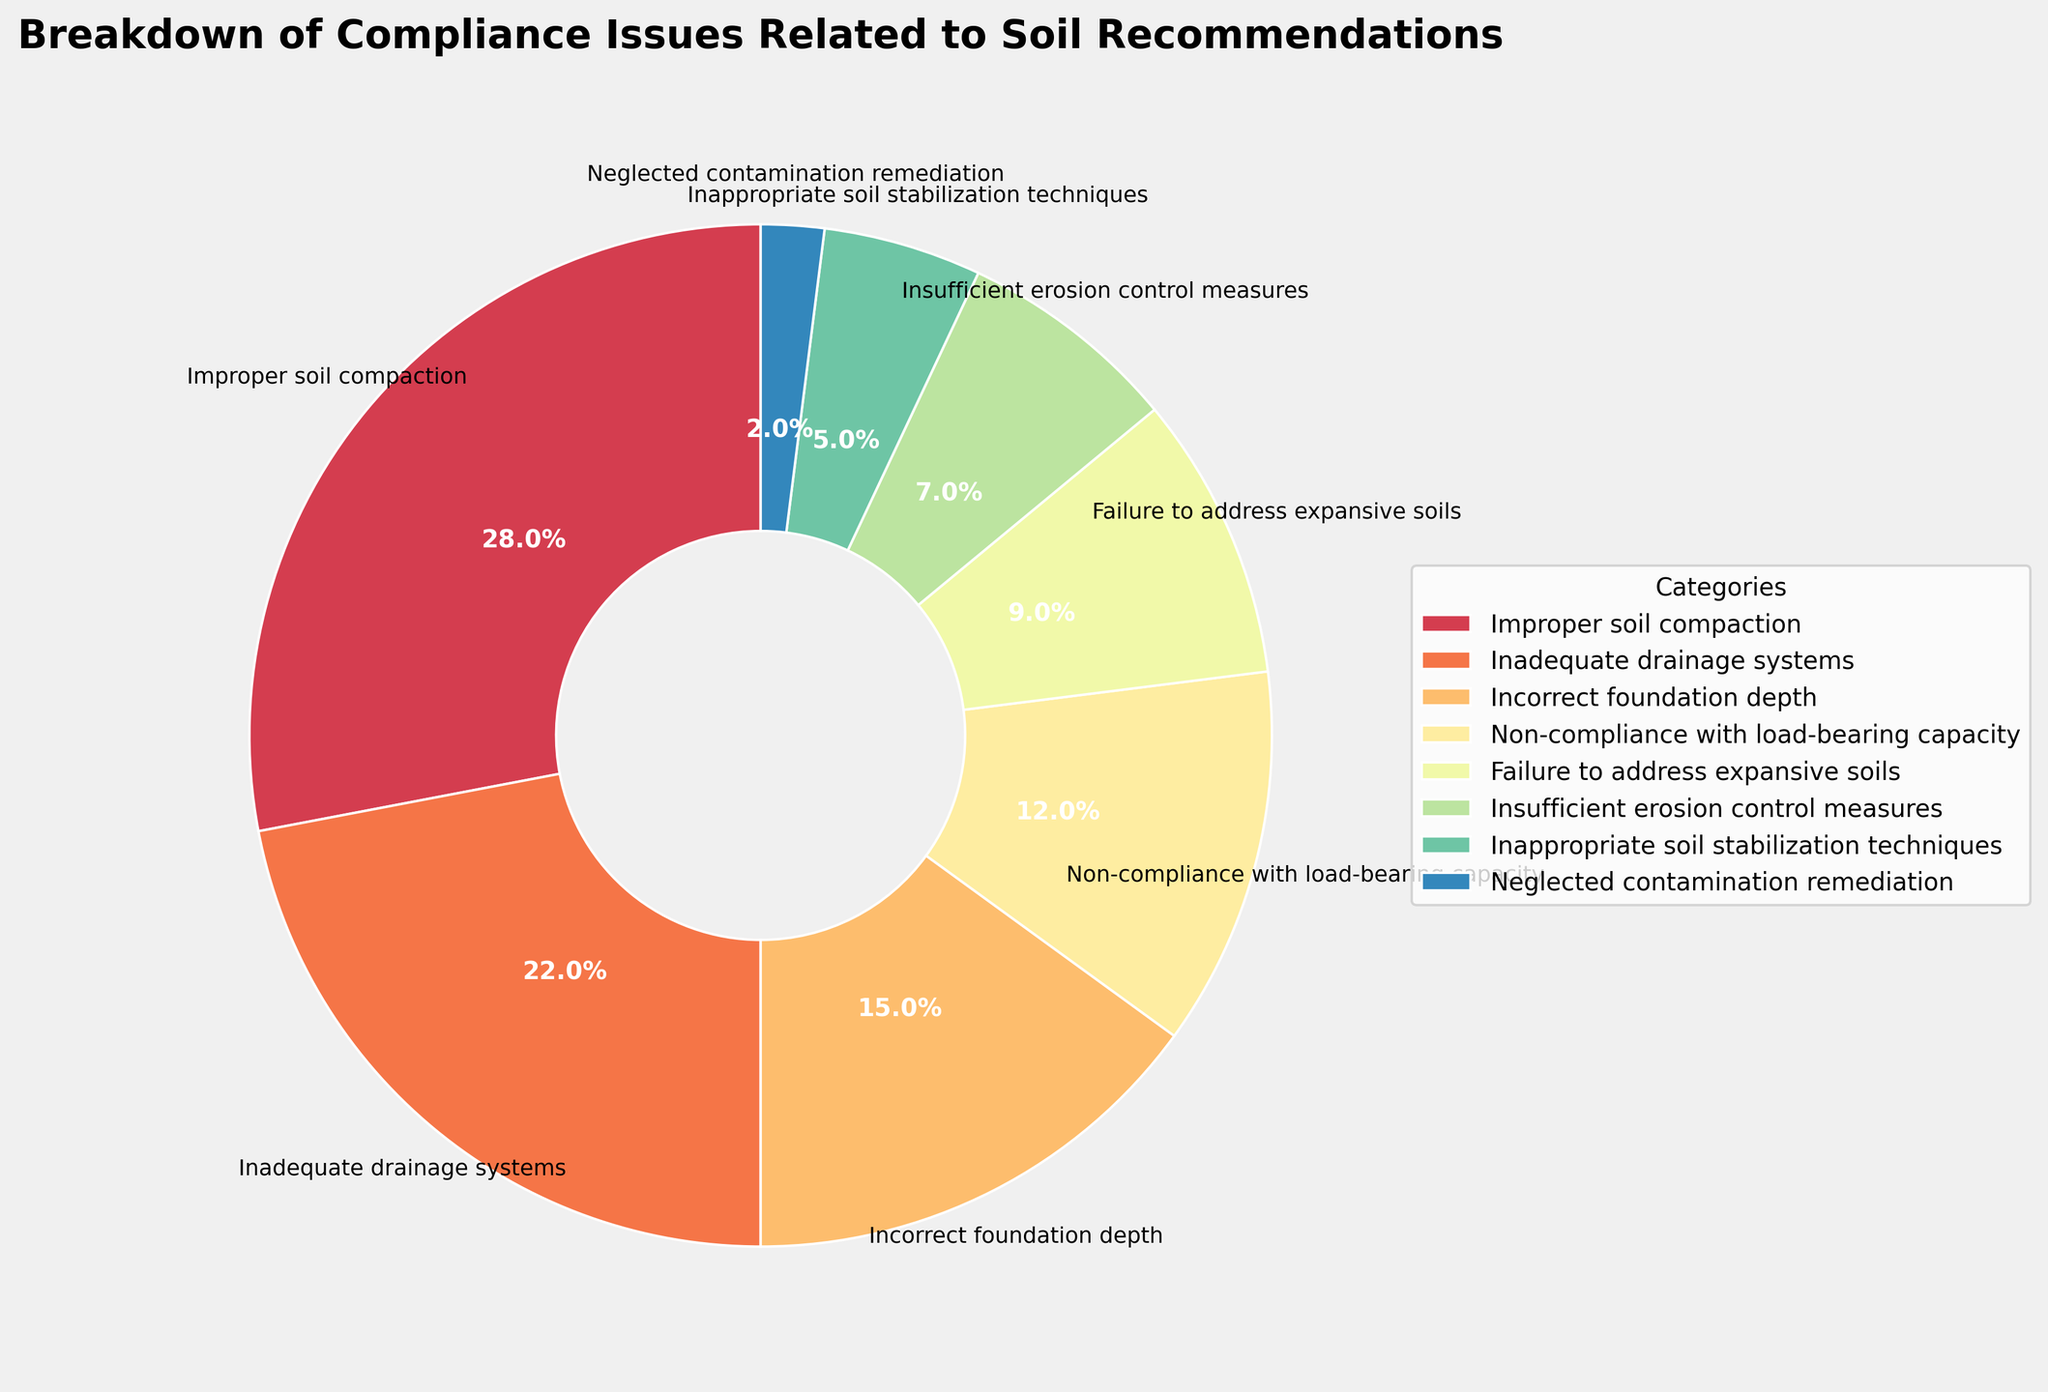Which category has the highest percentage of compliance issues? The category with the highest percentage will be the largest segment in the pie chart.
Answer: Improper soil compaction Which two categories combined make up more than 40% of the compliance issues? Identify the percentages of each category and sum up the top two highest percentages to see if they exceed 40%. Improper soil compaction (28%) and inadequate drainage systems (22%) together make up 50%.
Answer: Improper soil compaction and inadequate drainage systems Which category has the least percentage of compliance issues? The smallest segment in the pie chart corresponds to the category with the lowest percentage.
Answer: Neglected contamination remediation What is the difference in percentage points between the category with the highest and the category with the lowest compliance issues? Subtract the percentage of the smallest segment (2%) from the largest segment (28%). 28% - 2% = 26%
Answer: 26% What percentage of compliance issues are related to incorrect foundation depth or non-compliance with load-bearing capacity? Sum the percentages of the segments for "Incorrect foundation depth" (15%) and "Non-compliance with load-bearing capacity" (12%). 15% + 12% = 27%
Answer: 27% Which two categories have a combined percentage equal to the category with the highest compliance issues? Compare sums of two categories with the highest single category (28%). Non-compliance with load-bearing capacity (12%) and incorrect foundation depth (15%) together total 27%, which is closest.
Answer: Non-compliance with load-bearing capacity and incorrect foundation depth What visual attribute is used to differentiate the categories in the pie chart? The segments in the pie chart are differentiated by their colors.
Answer: Colors How many categories have a percentage lower than 10%? Identify segments with percentages below 10%. Here, failure to address expansive soils (9%), insufficient erosion control measures (7%), inappropriate soil stabilization techniques (5%), and neglected contamination remediation (2%), yielding four categories.
Answer: Four What is the sum of the percentages for categories related to soil stability issues? Relevant categories: improper soil compaction (28%), failure to address expansive soils (9%), insufficient erosion control measures (7%), and inappropriate soil stabilization techniques (5%). Summing them gives 28 + 9 + 7 + 5 = 49%.
Answer: 49% Are the colors of the segments in the pie chart similar or distinct from each other? The pie chart uses distinct colors for each segment to visually differentiate the categories.
Answer: Distinct 